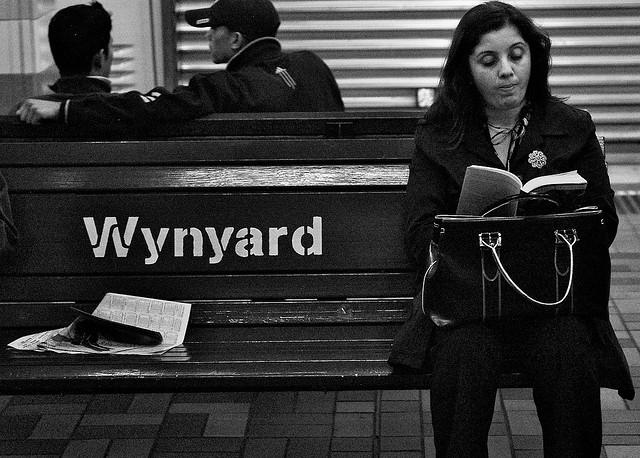What is the woman focusing on?
Short answer required. Book. Does this woman have good eyesight?
Write a very short answer. Yes. What color is this picture taken in?
Keep it brief. Black and white. 